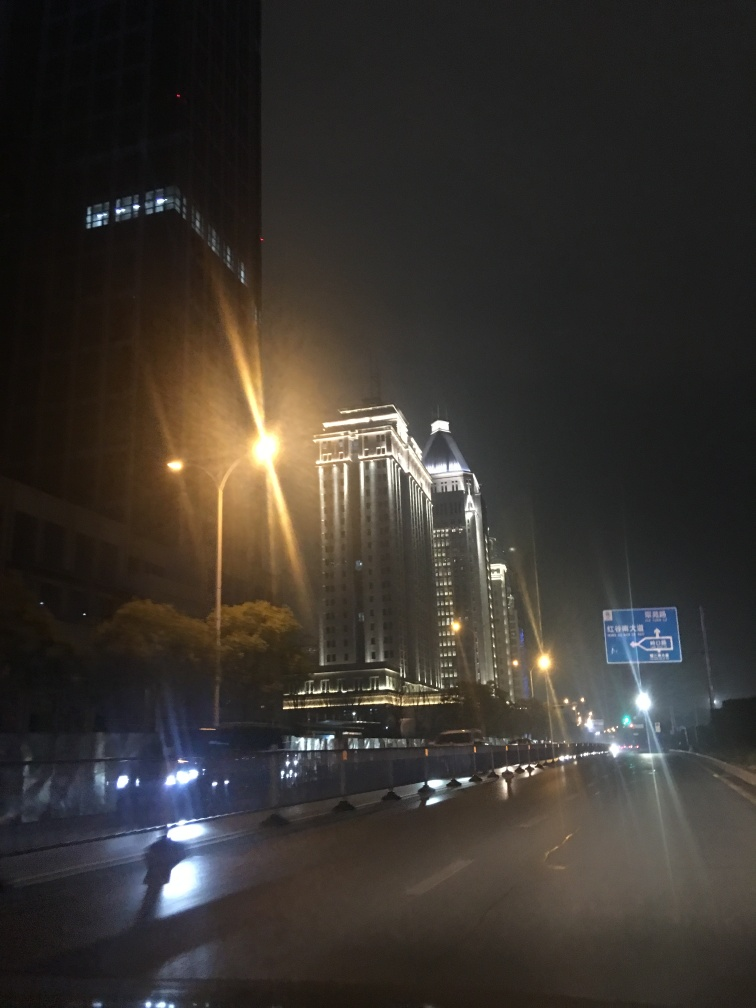How might the time of day affect the activity in this area? Given it's nighttime, activity on the streets would likely be reduced compared to the daytime. Shops may be closed, and the number of pedestrians and vehicles is probably lower. This time might also invite a different demographic, such as late-shift workers or those enjoying the city's nightlife, contributing to a more subdued or specific type of activity. What architectural styles can we observe in the buildings displayed? The buildings exhibit modern architectural elements juxtaposed with classical design cues. The illuminated building to the right has a traditional dome-topped tower, indicative of neoclassical or Beaux-Arts influence, while the adjacent structures appear to possess modern commercial architecture typical of late 20th or early 21st century design. 